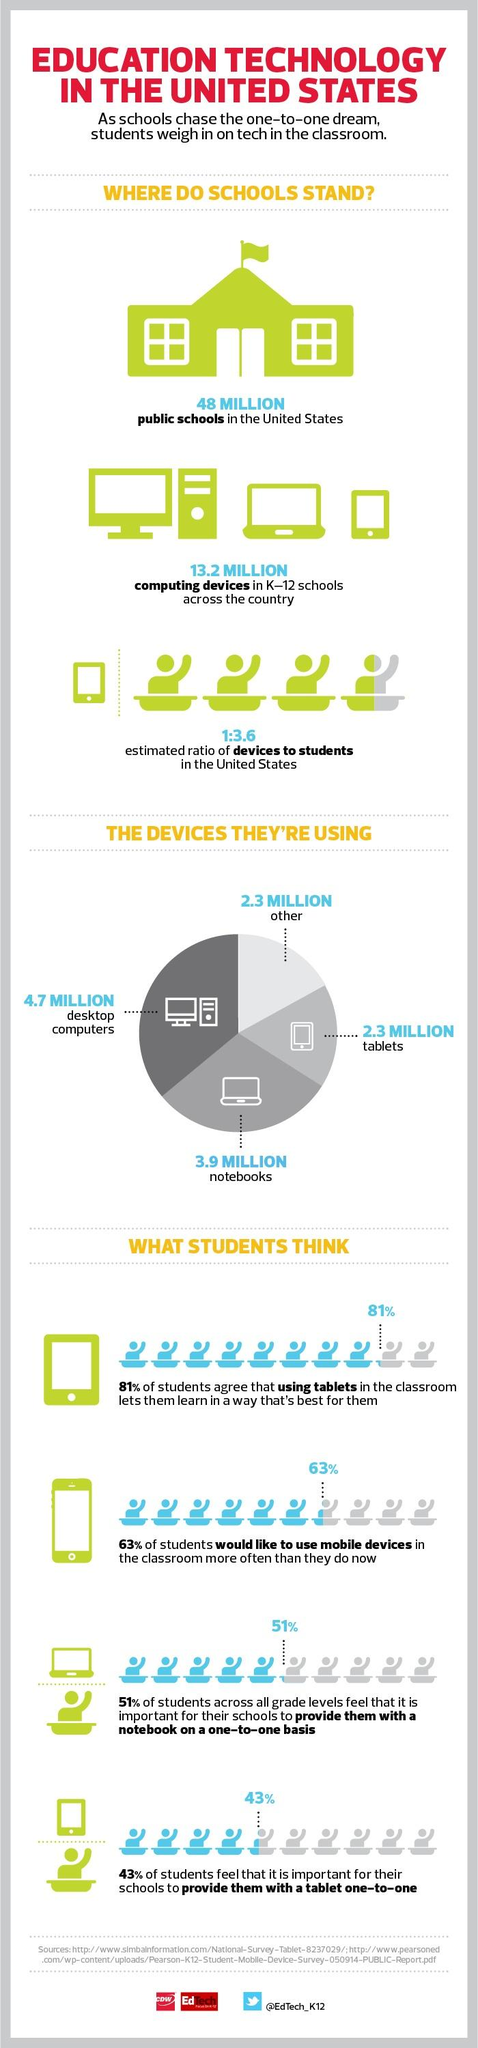Outline some significant characteristics in this image. According to a survey of students, a majority of 57% feel that it is not important for schools to provide them with a tablet one-to-one. The second most commonly used device by students is notebooks. 